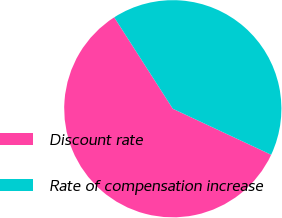<chart> <loc_0><loc_0><loc_500><loc_500><pie_chart><fcel>Discount rate<fcel>Rate of compensation increase<nl><fcel>58.97%<fcel>41.03%<nl></chart> 